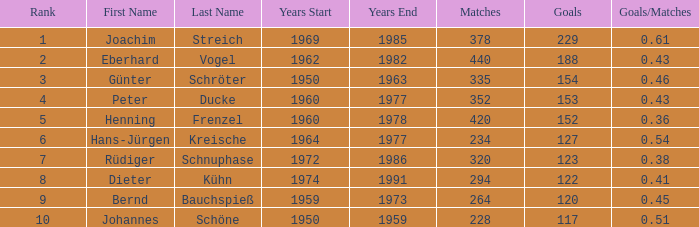What average goals have matches less than 228? None. 